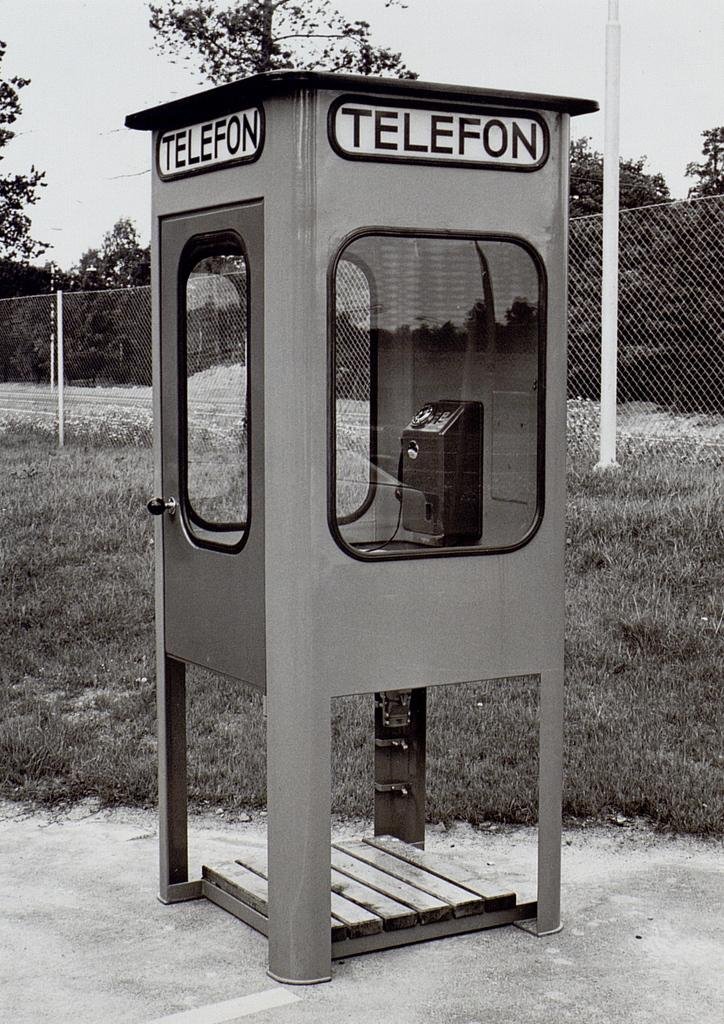<image>
Provide a brief description of the given image. A black and white phone booth that reads telefon on the top of it. 